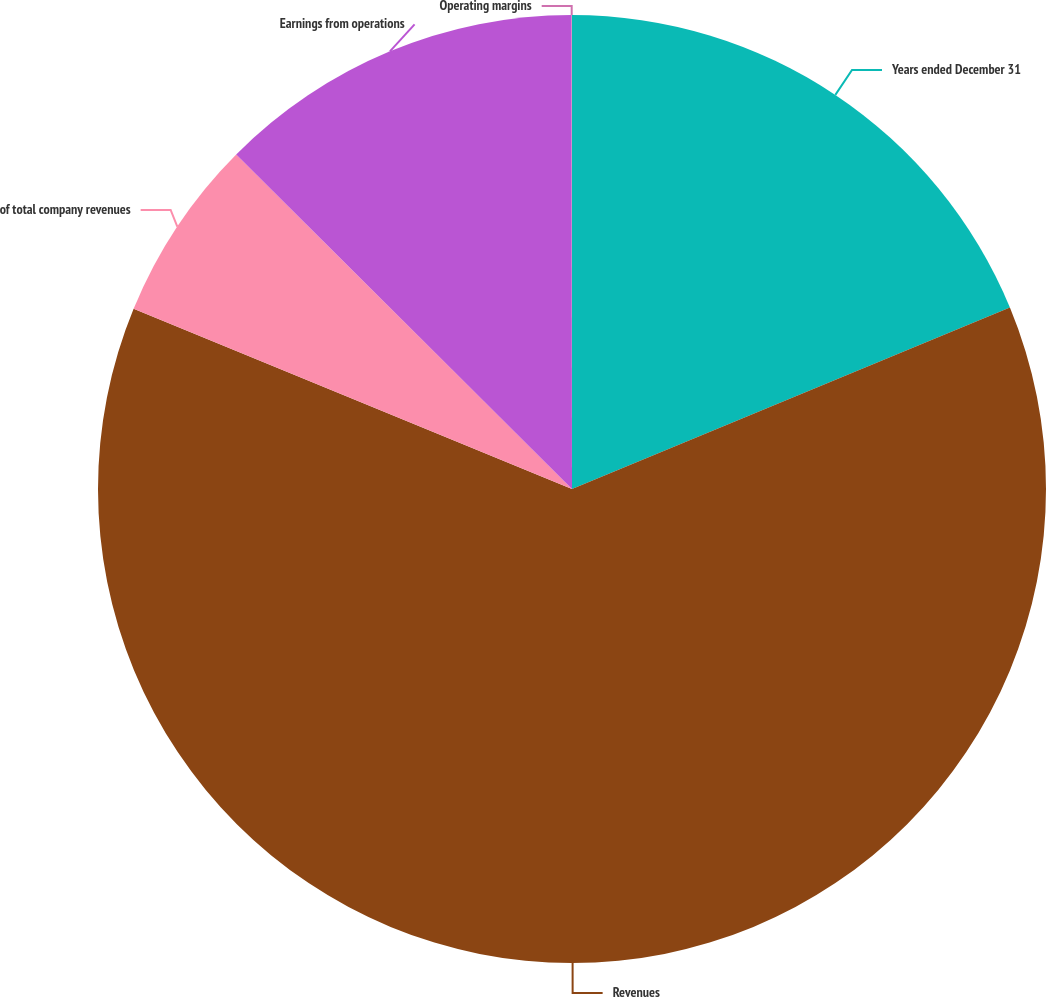Convert chart. <chart><loc_0><loc_0><loc_500><loc_500><pie_chart><fcel>Years ended December 31<fcel>Revenues<fcel>of total company revenues<fcel>Earnings from operations<fcel>Operating margins<nl><fcel>18.75%<fcel>62.46%<fcel>6.26%<fcel>12.51%<fcel>0.02%<nl></chart> 